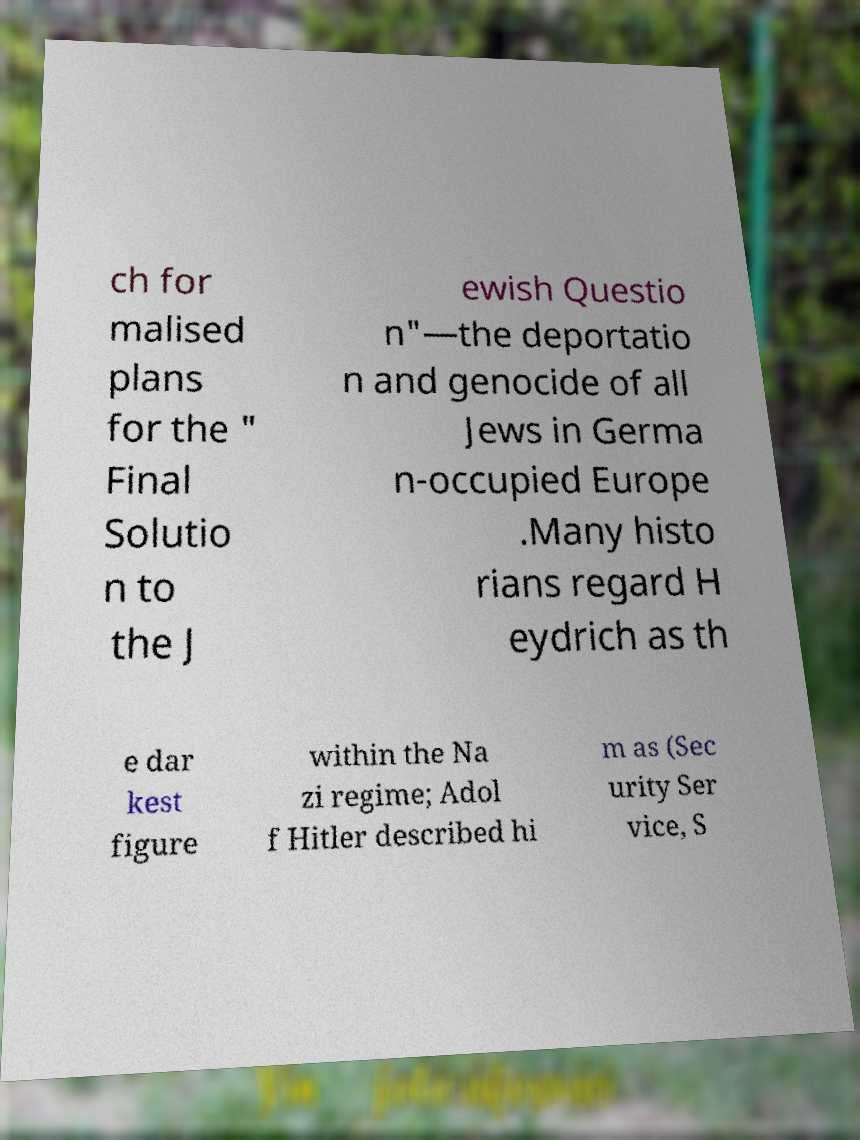Can you read and provide the text displayed in the image?This photo seems to have some interesting text. Can you extract and type it out for me? ch for malised plans for the " Final Solutio n to the J ewish Questio n"—the deportatio n and genocide of all Jews in Germa n-occupied Europe .Many histo rians regard H eydrich as th e dar kest figure within the Na zi regime; Adol f Hitler described hi m as (Sec urity Ser vice, S 